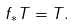<formula> <loc_0><loc_0><loc_500><loc_500>f _ { * } T = T .</formula> 